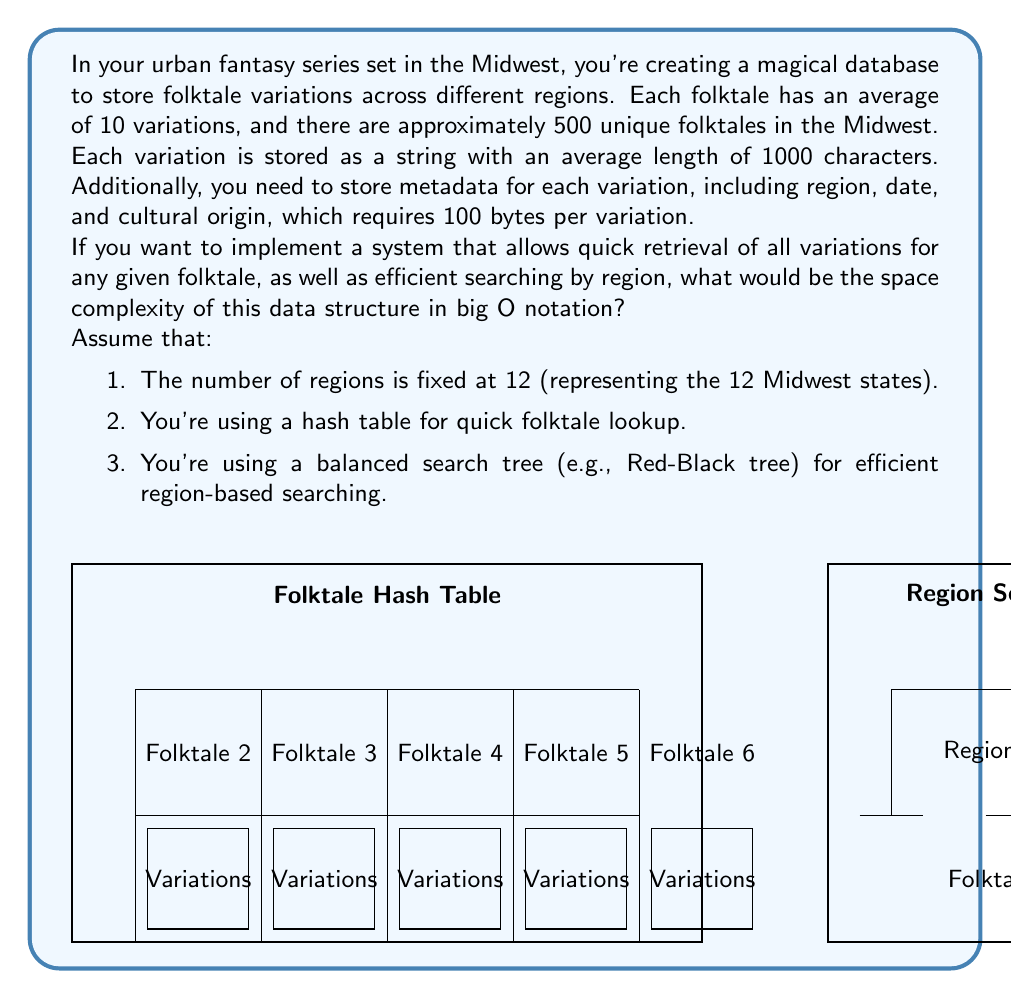Can you solve this math problem? To determine the space complexity, let's break down the components of our data structure:

1. Folktale variations storage:
   - Number of folktales: 500
   - Average variations per folktale: 10
   - Total variations: $500 \times 10 = 5000$
   - Each variation: 1000 characters + 100 bytes metadata
   - Space per variation: $1000 \times 2$ bytes (assuming UTF-16 encoding) $+ 100 = 2100$ bytes
   - Total space for variations: $5000 \times 2100 = 10,500,000$ bytes

2. Hash table for folktale lookup:
   - 500 entries (one per folktale)
   - Each entry contains a key (folktale name) and a pointer to the list of variations
   - Assuming 64-bit system: 8 bytes per pointer
   - Space for hash table: $500 \times (64 + 8) = 36,000$ bytes (assuming average folktale name is 64 bytes)

3. Balanced search tree for region-based searching:
   - 12 nodes (one per Midwest state)
   - Each node contains region info and references to folktales in that region
   - Worst case: all folktales exist in every region
   - Space per node: $64 + (500 \times 8) = 4,064$ bytes
   - Total space for tree: $12 \times 4,064 = 48,768$ bytes

Total space: $10,500,000 + 36,000 + 48,768 = 10,584,768$ bytes

The dominant factor here is the storage of folktale variations, which scales linearly with the number of folktales and variations. The hash table and search tree add negligible overhead in comparison.

In big O notation, we express this as $O(F \times V \times L)$, where:
$F$ is the number of folktales
$V$ is the average number of variations per folktale
$L$ is the average length of each variation

The other factors (number of regions, metadata size) are considered constant and don't affect the asymptotic complexity.
Answer: $O(F \times V \times L)$ 